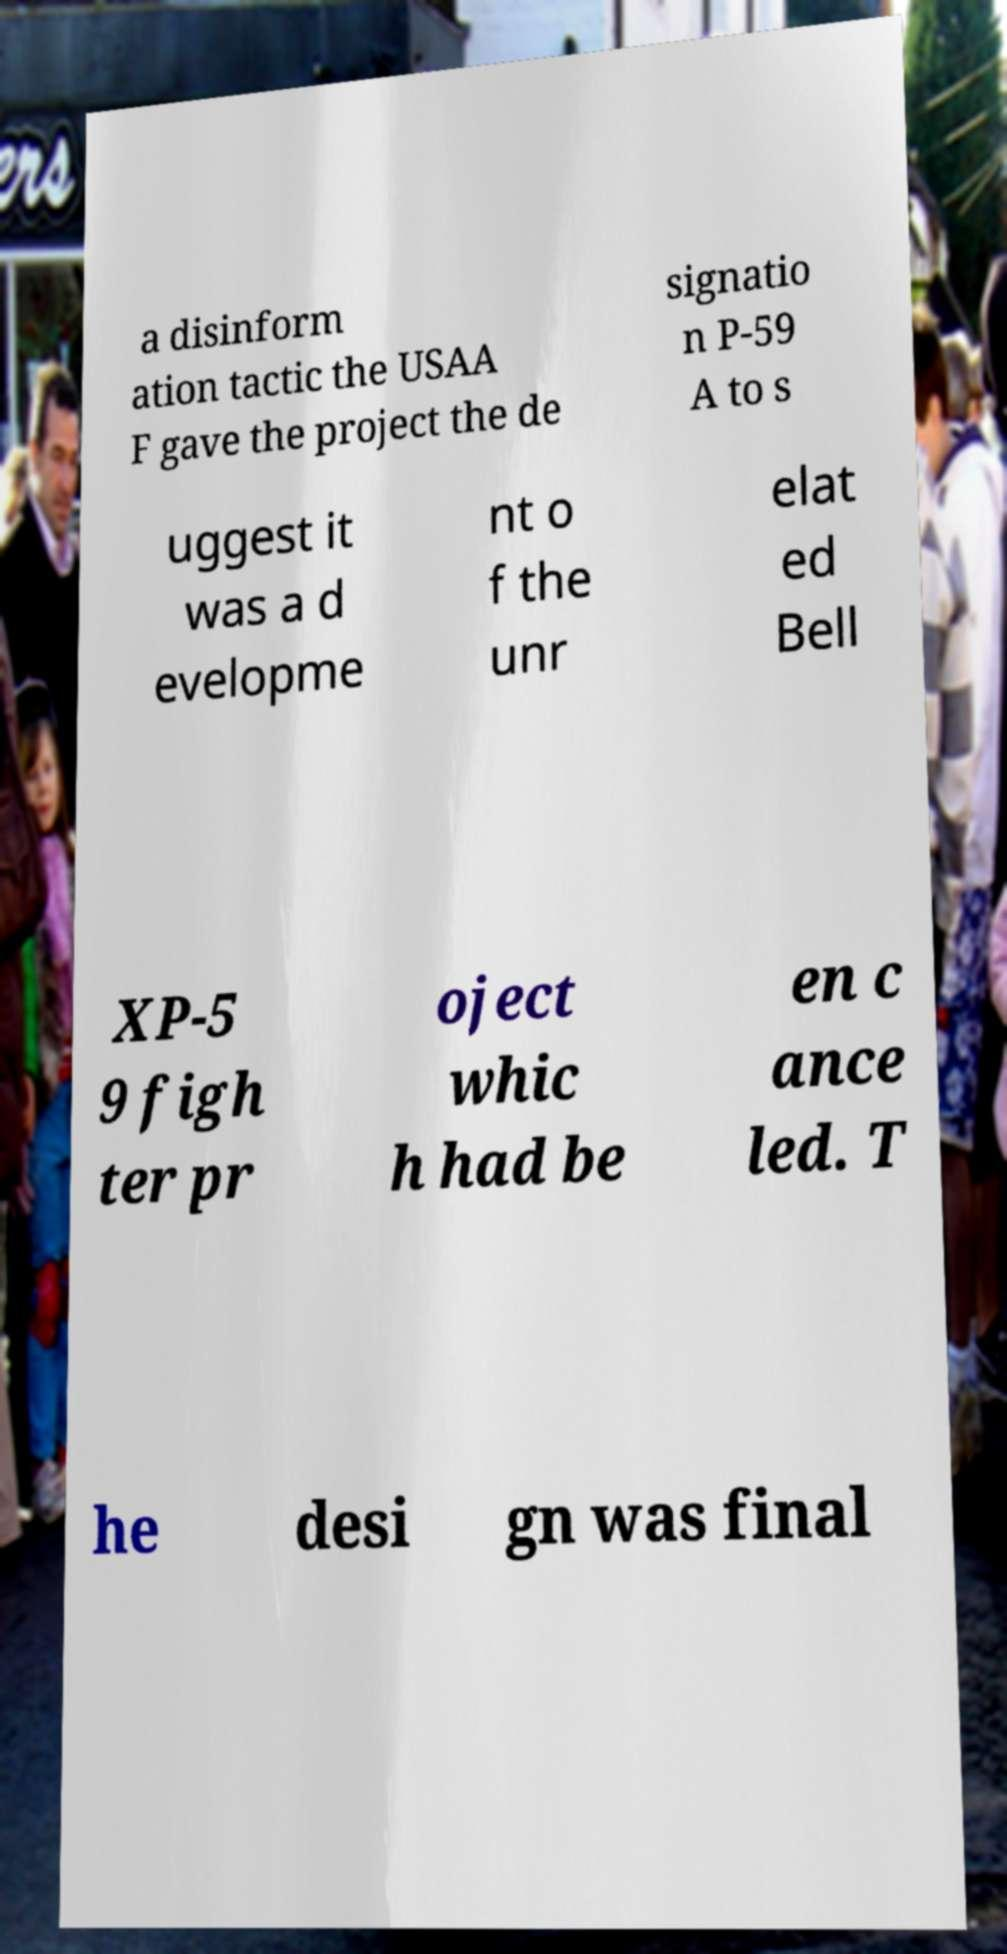I need the written content from this picture converted into text. Can you do that? a disinform ation tactic the USAA F gave the project the de signatio n P-59 A to s uggest it was a d evelopme nt o f the unr elat ed Bell XP-5 9 figh ter pr oject whic h had be en c ance led. T he desi gn was final 